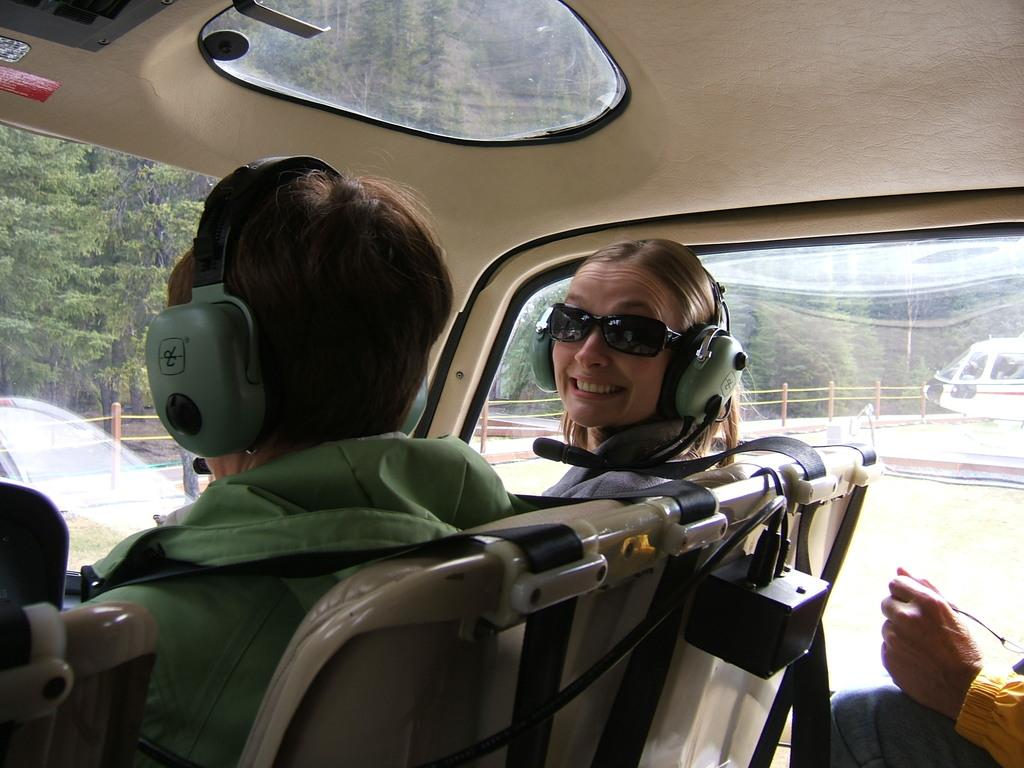What is happening in the image? There are people inside a vehicle in the image. What can be seen in the background of the image? There is an airplane, a fence, trees, and some objects visible in the background of the image. How many girls are playing with lizards in the image? There are no girls or lizards present in the image. 